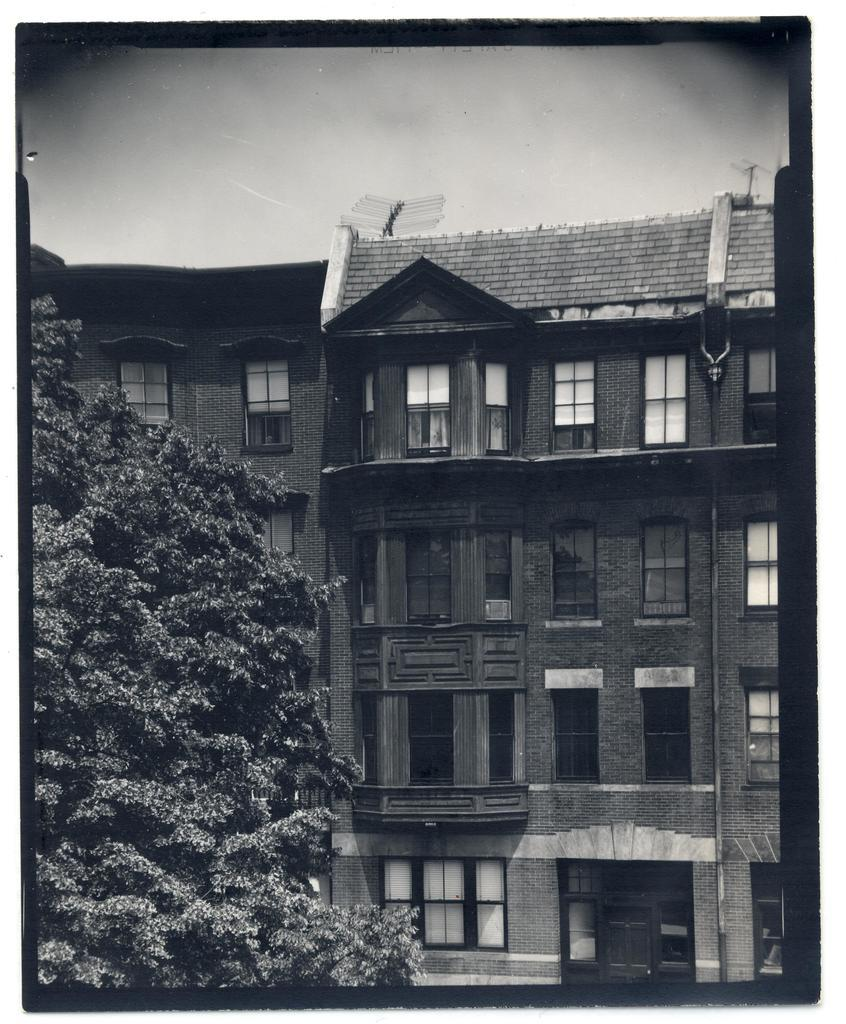What type of natural element is present in the image? There is a tree in the image. What type of structures are visible in the image? There are buildings with windows in the image. What features do the buildings have? The buildings have doors and pipes. What can be seen in the background of the image? The sky is visible in the background of the image. Where is the camp located in the image? There is no camp present in the image. What type of berry can be seen growing on the tree in the image? There is no berry present on the tree in the image. 